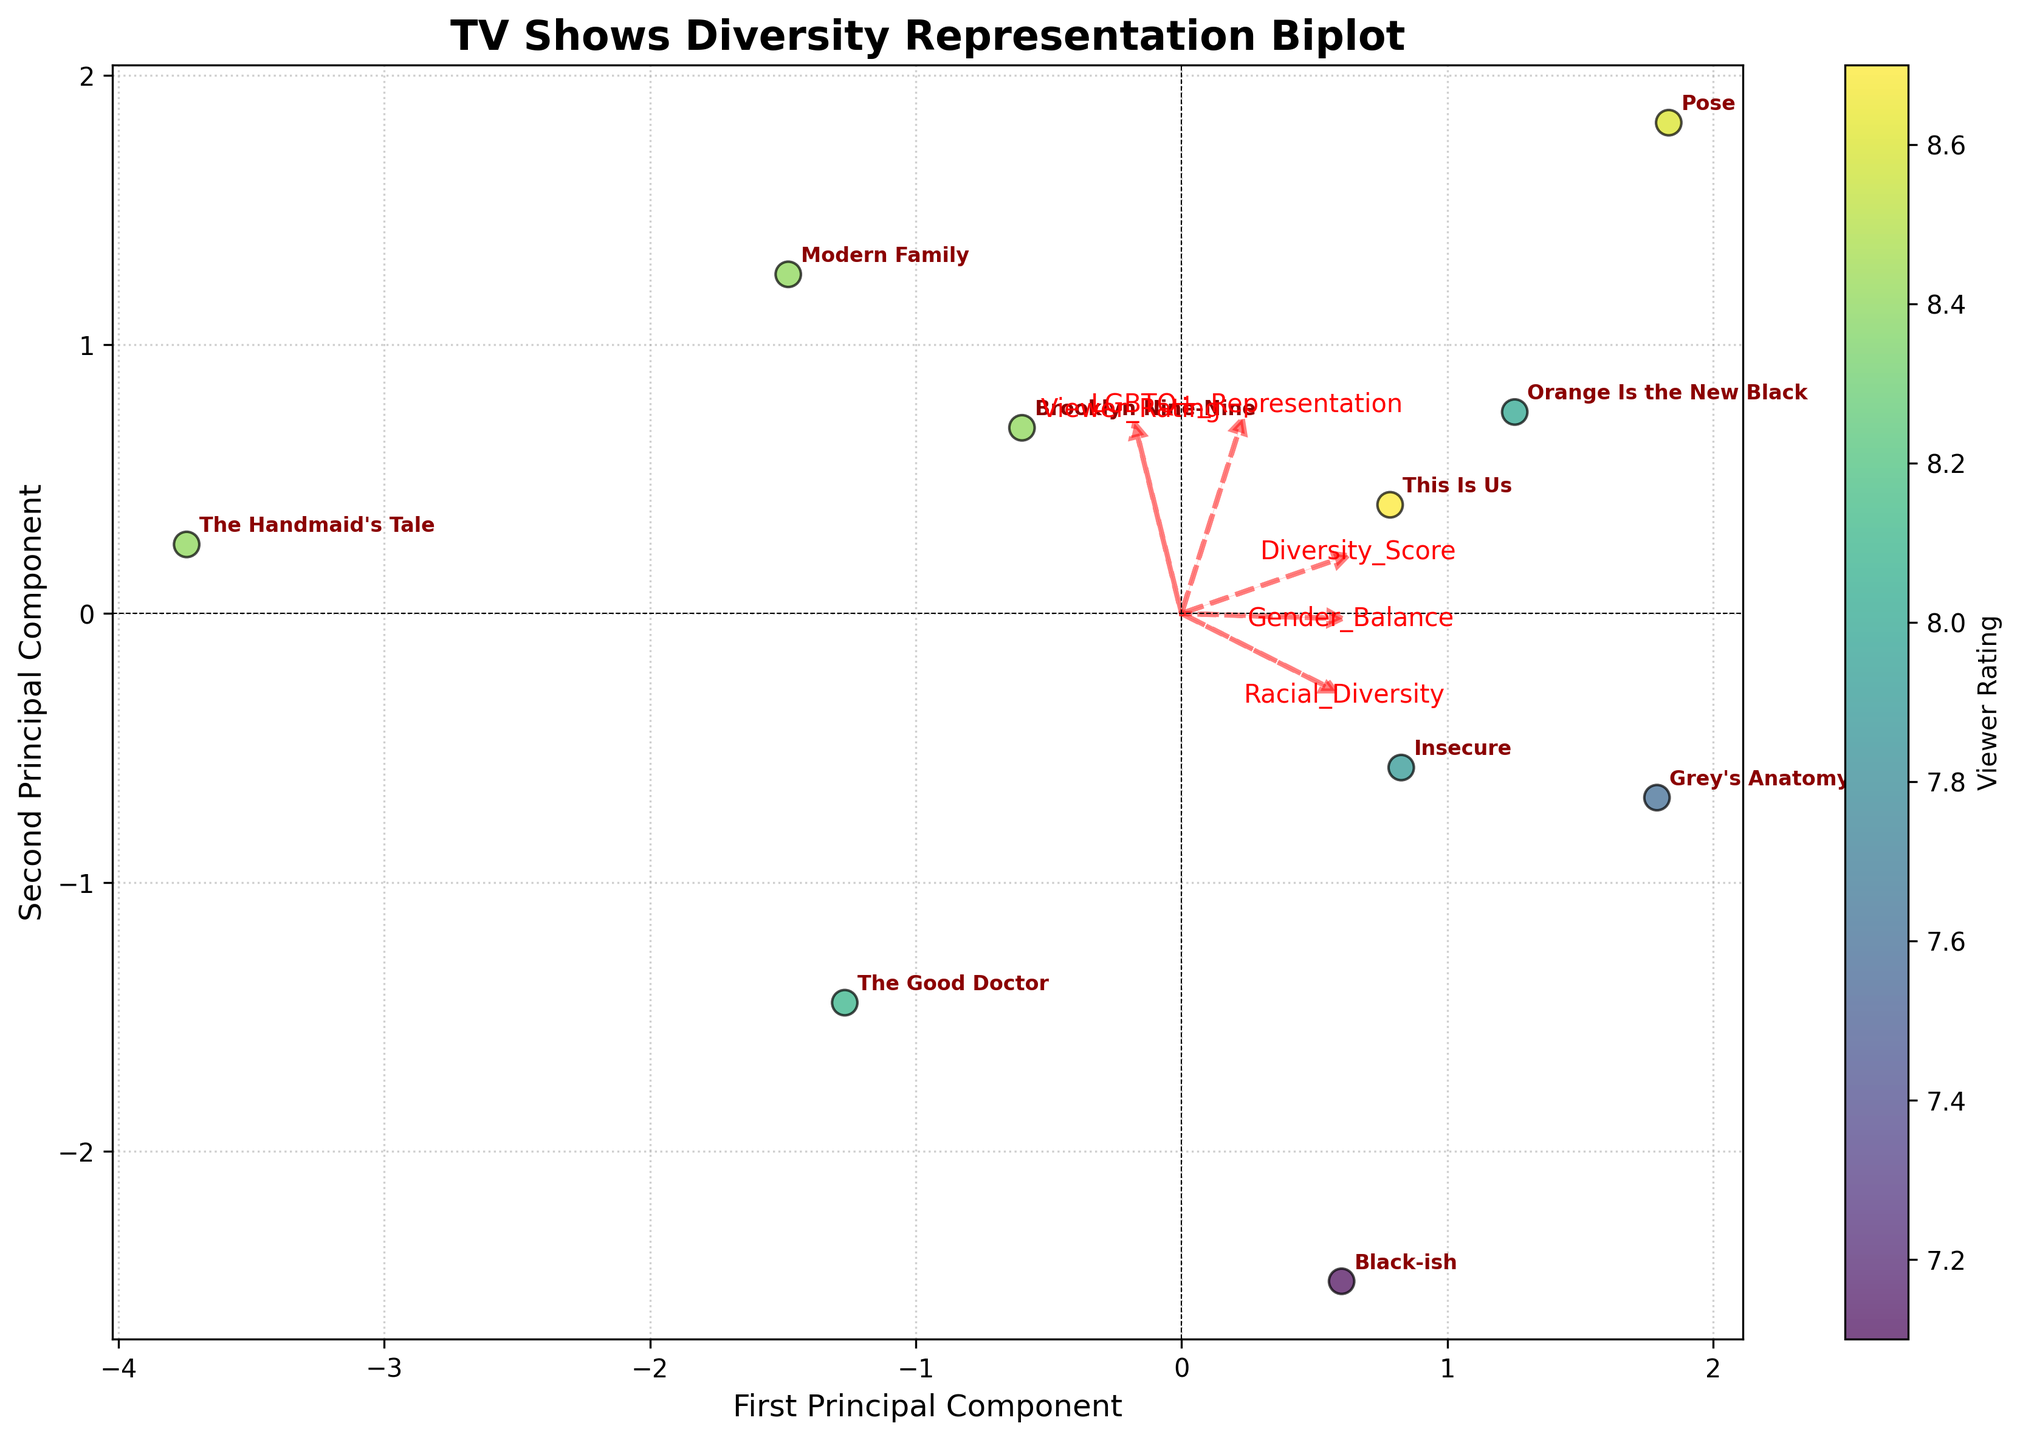What is the title of the plot? The title of the plot is typically positioned at the top and is used to summarize what the visual represents. In this plot, the title says "TV Shows Diversity Representation Biplot".
Answer: TV Shows Diversity Representation Biplot How many TV shows are represented in the plot? To find the number of TV shows represented, count the number of labels (names of TV shows) annotated on the plot.
Answer: 10 Which TV show has the highest viewer rating? Look for the point corresponding to the highest color value on the color scale (mapped to viewer rating), then check the nearest show label.
Answer: This Is Us Which features are closely related according to their feature vectors in the plot? Examine the directions and closeness of the feature vectors. Closely aligned vectors suggest correlation. In this plot, "Viewer Rating" and "Diversity Score" vectors point in similar directions.
Answer: Viewer Rating and Diversity Score Which TV show has the lowest diversity score? Identify the point closest to the start of the "Diversity Score" vector by looking at its direction. Check the nearest show label to that point.
Answer: The Handmaid's Tale How are Viewer Rating and Diversity Score related based on the plot? Observe the direction and length of the feature vectors for Viewer Rating and Diversity Score. Vectors pointing in similar directions with similar lengths suggest a positive relationship.
Answer: Positively related Which feature seems to have the least impact on the viewer ratings based on the feature vectors? Look at the length and direction of the feature vectors relative to the Viewer Rating vector. The shorter and less aligned the vector, the less impact it suggests. "Gender Balance" has the shortest vector distance from the rest.
Answer: Gender Balance Is there any TV show with both high LGBTQ+ Representation and high Viewer Rating? Find the vector for LGBTQ+ Representation and Viewer Rating, then locate points near the end of both vectors. Annotate the show label closest to these points.
Answer: Pose What can be inferred about "Orange Is the New Black" in relation to racial diversity and viewer rating? Locate "Orange Is the New Black" and its proximity to the racial diversity vector and the viewer rating vector. Being close to both suggests high values in these features.
Answer: High in both racial diversity and viewer rating Compare "Brooklyn Nine-Nine" and "Black-ish" in terms of gender balance and viewer rating. Which show scores better? Identify the points for "Brooklyn Nine-Nine" and "Black-ish", then check their positions relative to the feature vectors for gender balance and viewer rating. "Brooklyn Nine-Nine" is higher on both counts.
Answer: Brooklyn Nine-Nine 